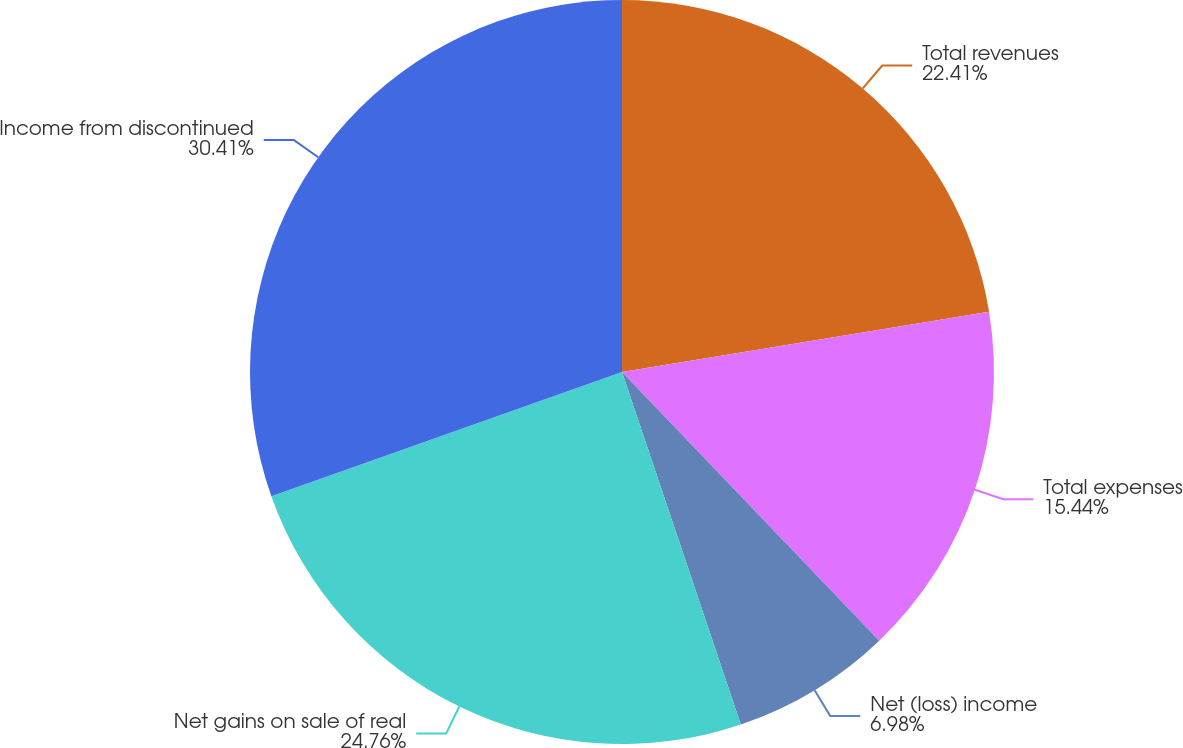<chart> <loc_0><loc_0><loc_500><loc_500><pie_chart><fcel>Total revenues<fcel>Total expenses<fcel>Net (loss) income<fcel>Net gains on sale of real<fcel>Income from discontinued<nl><fcel>22.41%<fcel>15.44%<fcel>6.98%<fcel>24.76%<fcel>30.42%<nl></chart> 